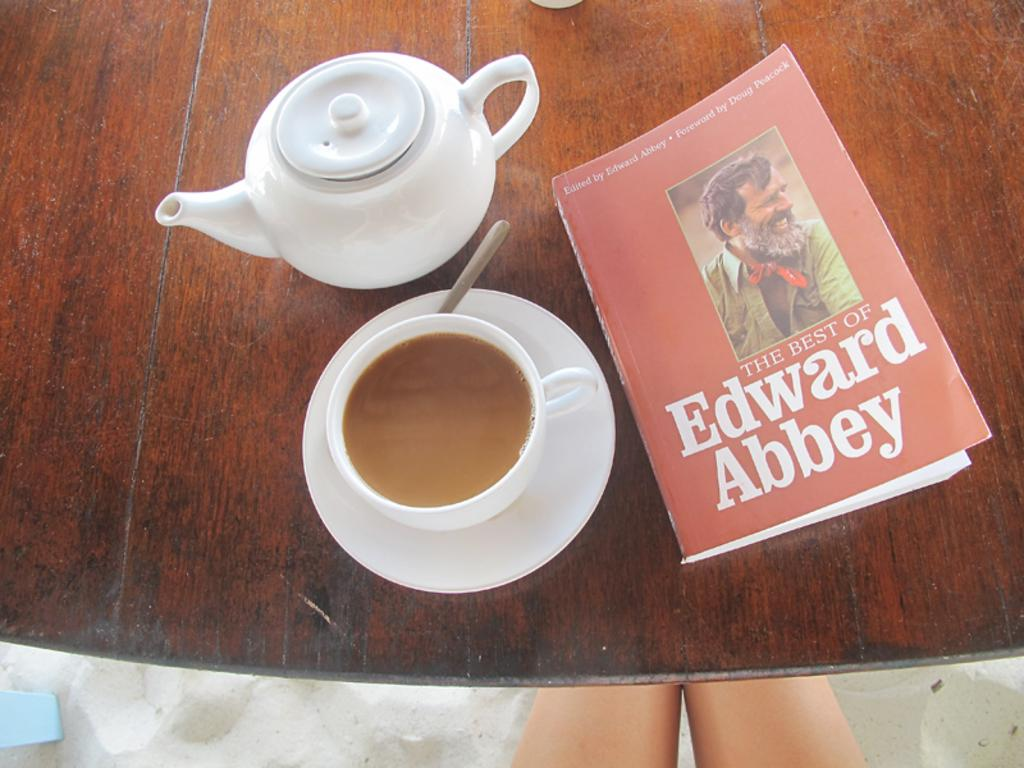What piece of furniture is present in the image? There is a table in the image. What objects are on the table? There is a book, a teapot, a cup containing a teaspoon, and a saucer on the table. Can you describe the person's legs visible in the image? The person's legs are visible at the bottom of the image, but no other details about the person are provided. What type of glove is the person wearing in the image? There is no glove visible in the image; only the person's legs are visible. What organization is responsible for the arrangement of the objects on the table? There is no information provided about any organization being responsible for the arrangement of the objects on the table. 